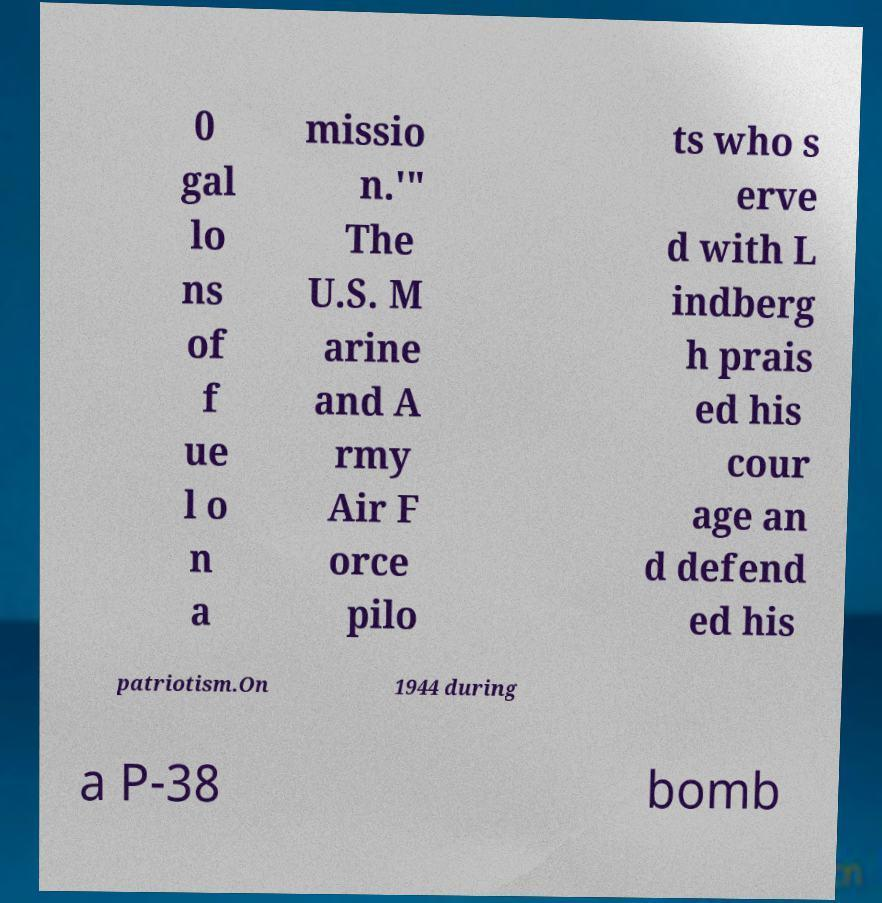Please identify and transcribe the text found in this image. 0 gal lo ns of f ue l o n a missio n.'" The U.S. M arine and A rmy Air F orce pilo ts who s erve d with L indberg h prais ed his cour age an d defend ed his patriotism.On 1944 during a P-38 bomb 